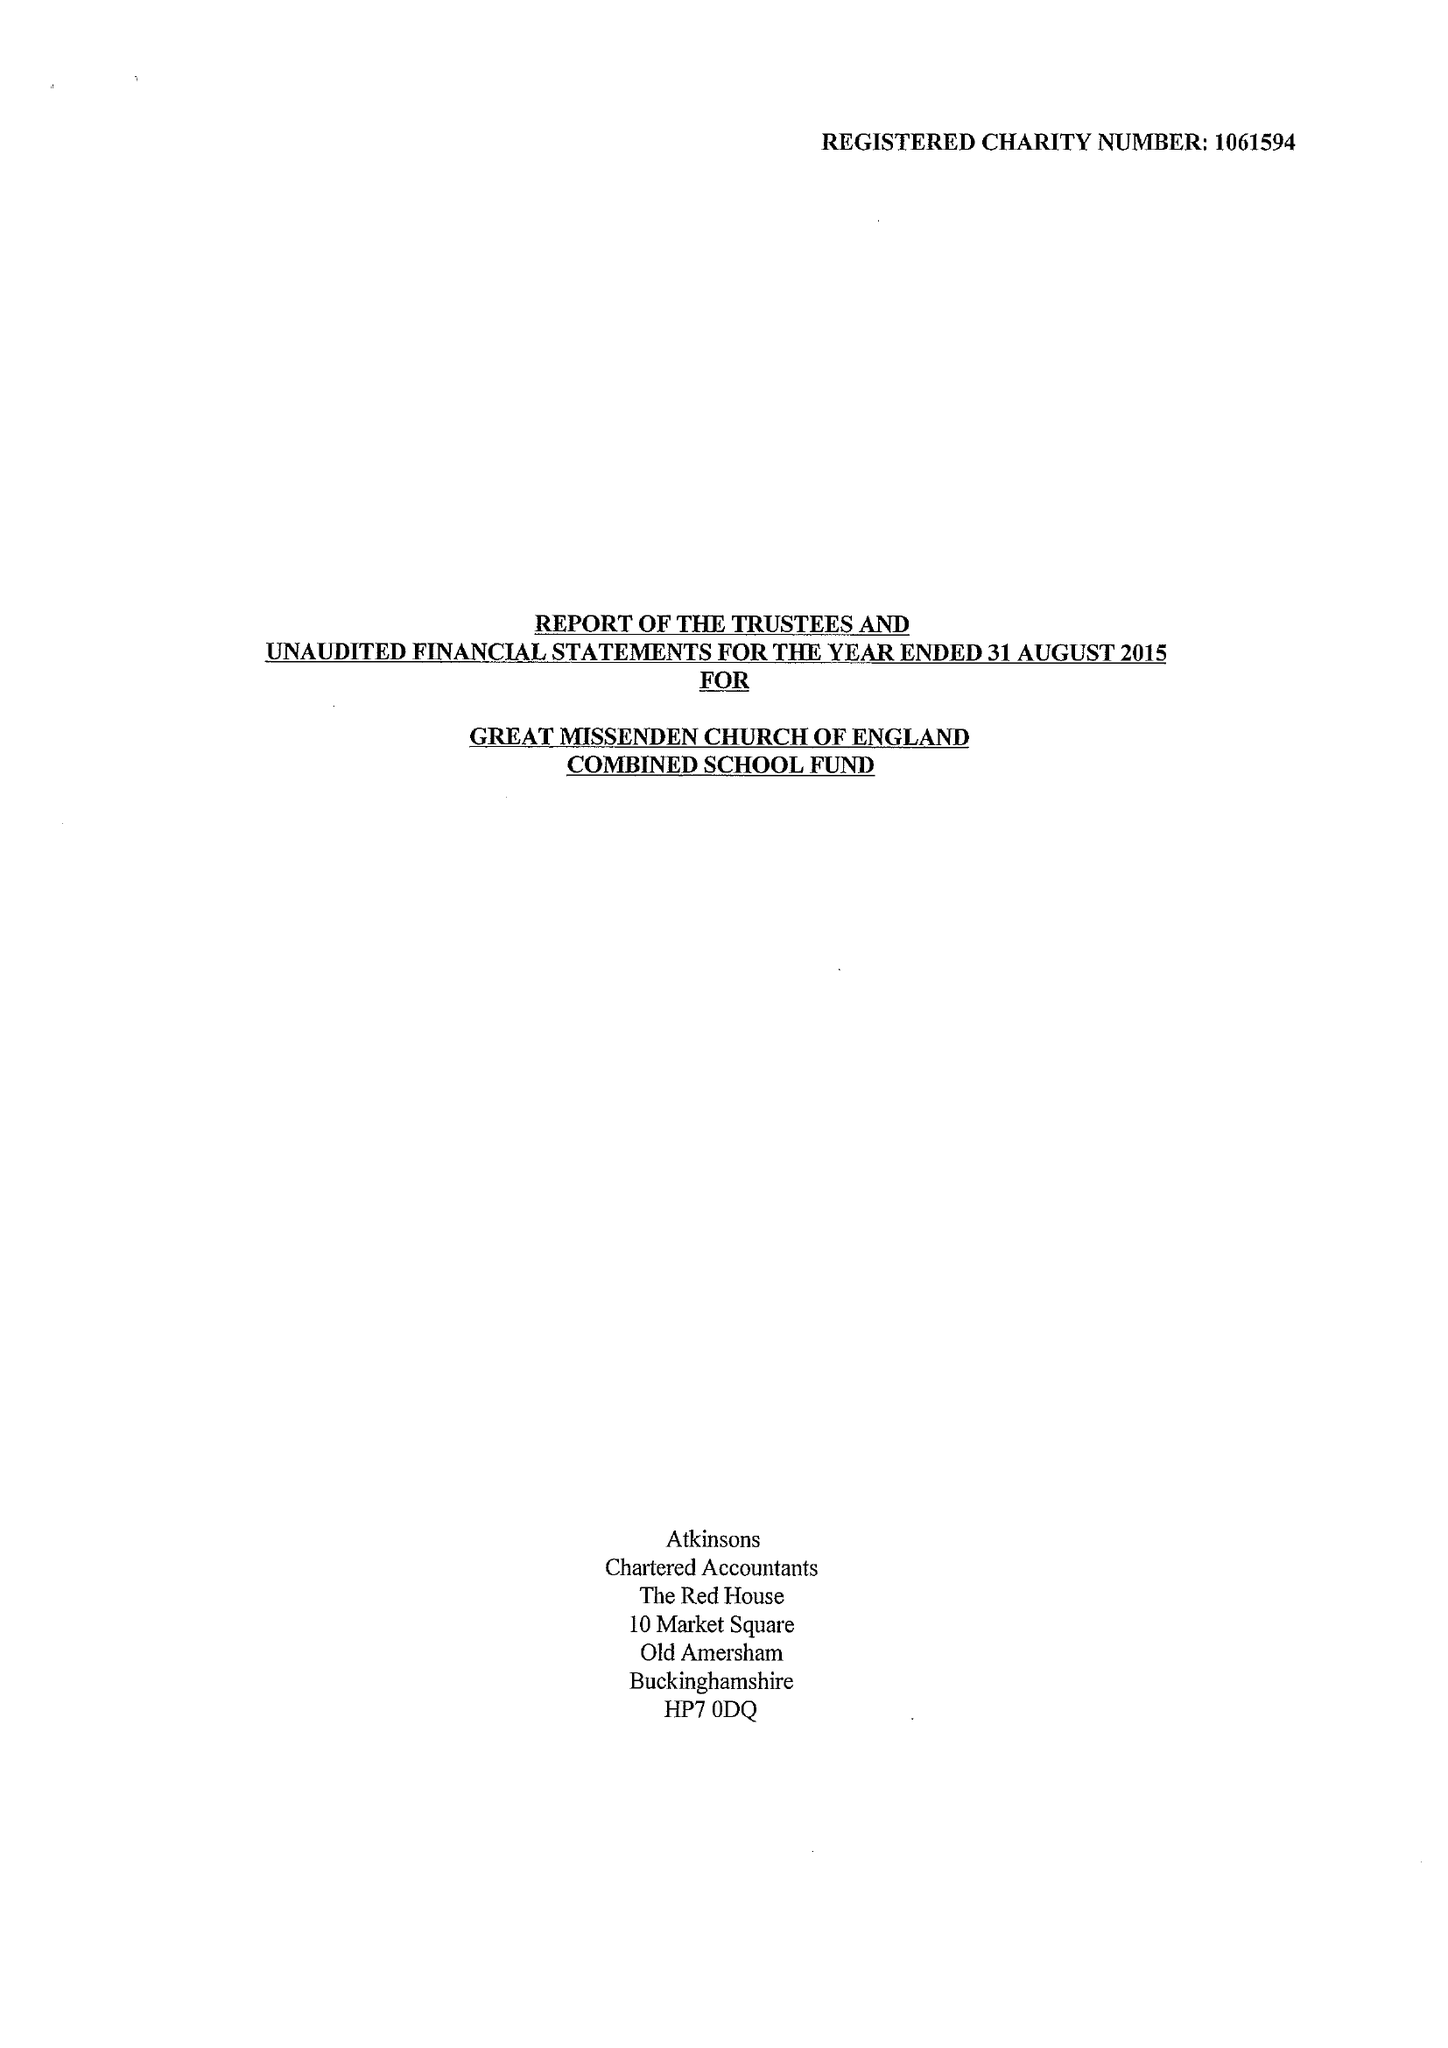What is the value for the address__post_town?
Answer the question using a single word or phrase. GREAT MISSENDEN 